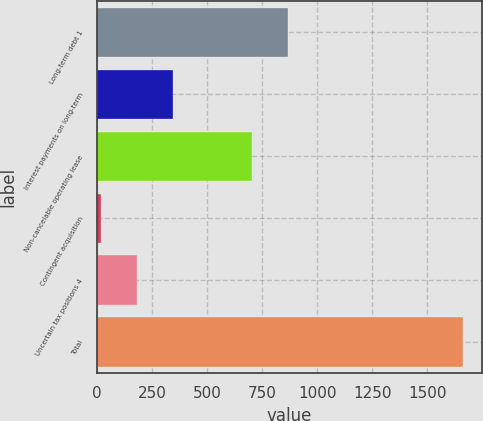<chart> <loc_0><loc_0><loc_500><loc_500><bar_chart><fcel>Long-term debt 1<fcel>Interest payments on long-term<fcel>Non-cancelable operating lease<fcel>Contingent acquisition<fcel>Uncertain tax positions 4<fcel>Total<nl><fcel>867.61<fcel>345.62<fcel>702.7<fcel>15.8<fcel>180.71<fcel>1664.9<nl></chart> 